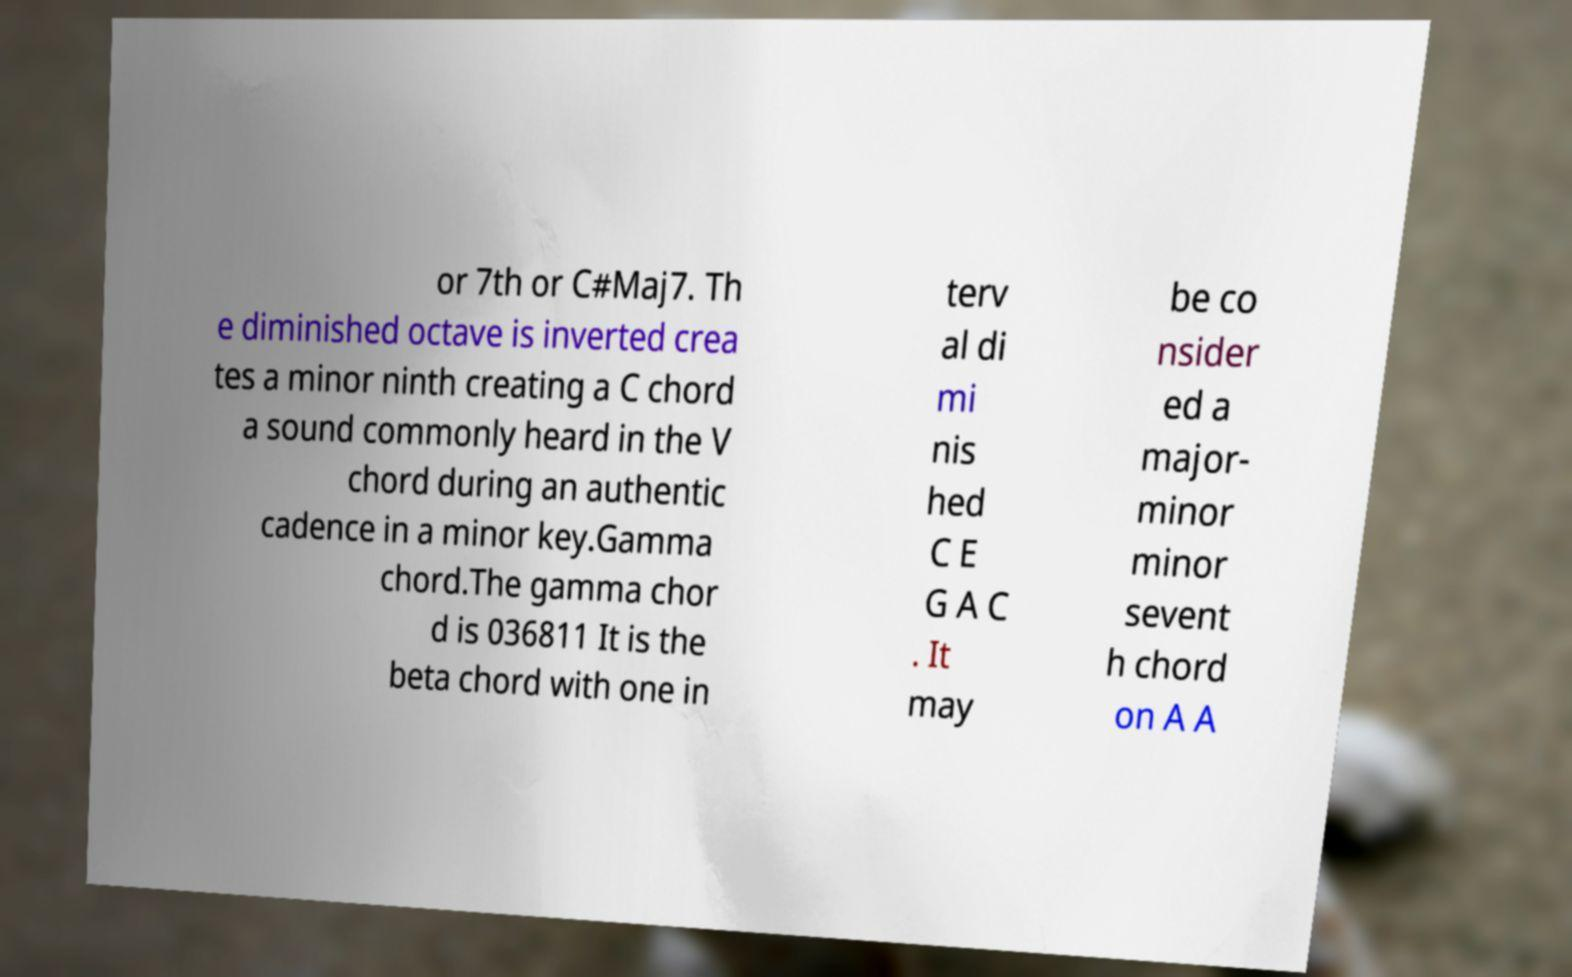I need the written content from this picture converted into text. Can you do that? or 7th or C#Maj7. Th e diminished octave is inverted crea tes a minor ninth creating a C chord a sound commonly heard in the V chord during an authentic cadence in a minor key.Gamma chord.The gamma chor d is 036811 It is the beta chord with one in terv al di mi nis hed C E G A C . It may be co nsider ed a major- minor minor sevent h chord on A A 